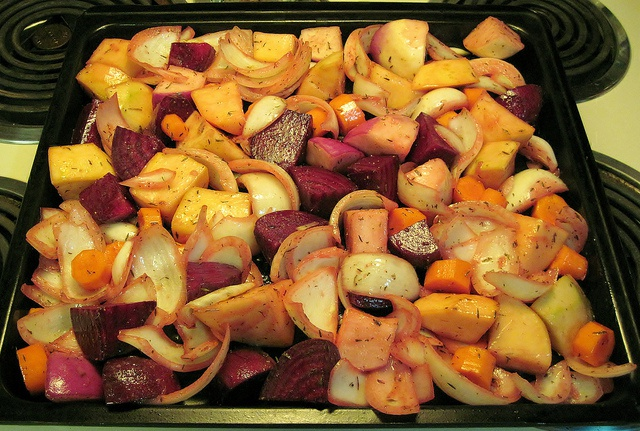Describe the objects in this image and their specific colors. I can see oven in black, khaki, darkgreen, and tan tones, carrot in black, red, and orange tones, carrot in black, orange, brown, and maroon tones, carrot in black, red, orange, brown, and maroon tones, and carrot in black, red, orange, and brown tones in this image. 